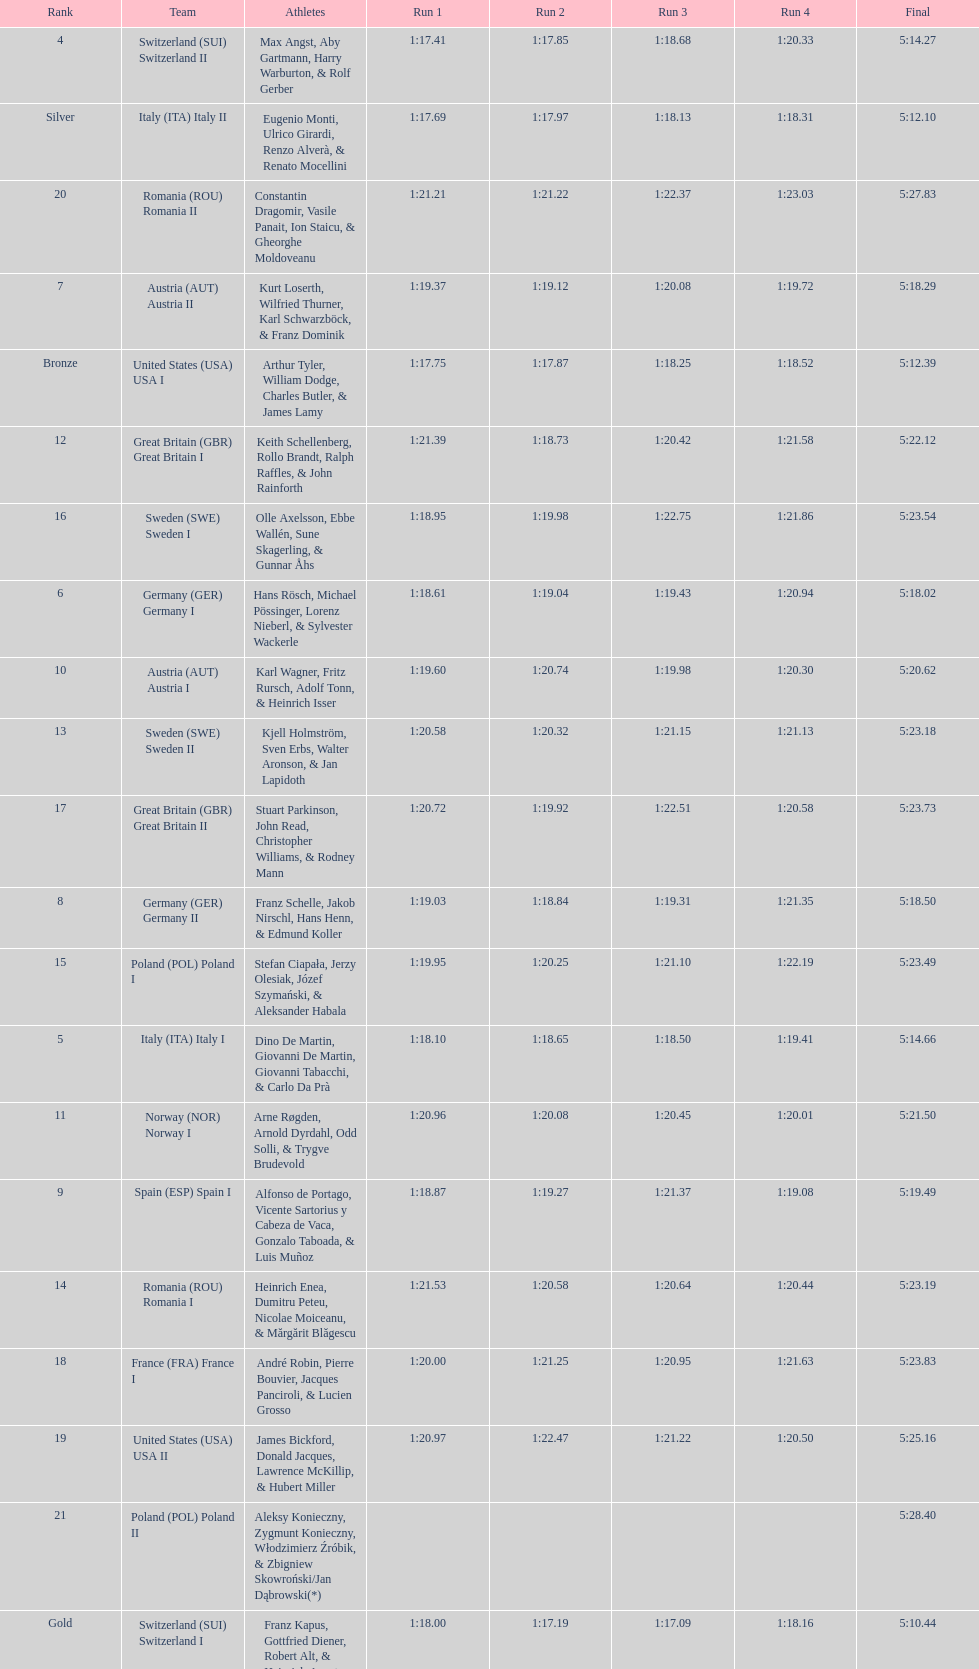What team comes after italy (ita) italy i? Germany I. 